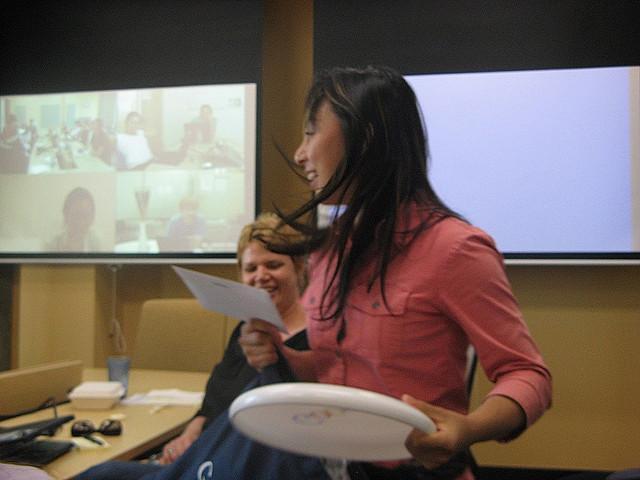How many girls are present?
Give a very brief answer. 2. How many women are in the picture?
Give a very brief answer. 2. How many frisbees can you see?
Give a very brief answer. 1. How many people can be seen?
Give a very brief answer. 3. How many tvs can you see?
Give a very brief answer. 2. How many street signs with a horse in it?
Give a very brief answer. 0. 